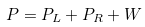<formula> <loc_0><loc_0><loc_500><loc_500>P = P _ { L } + P _ { R } + W</formula> 